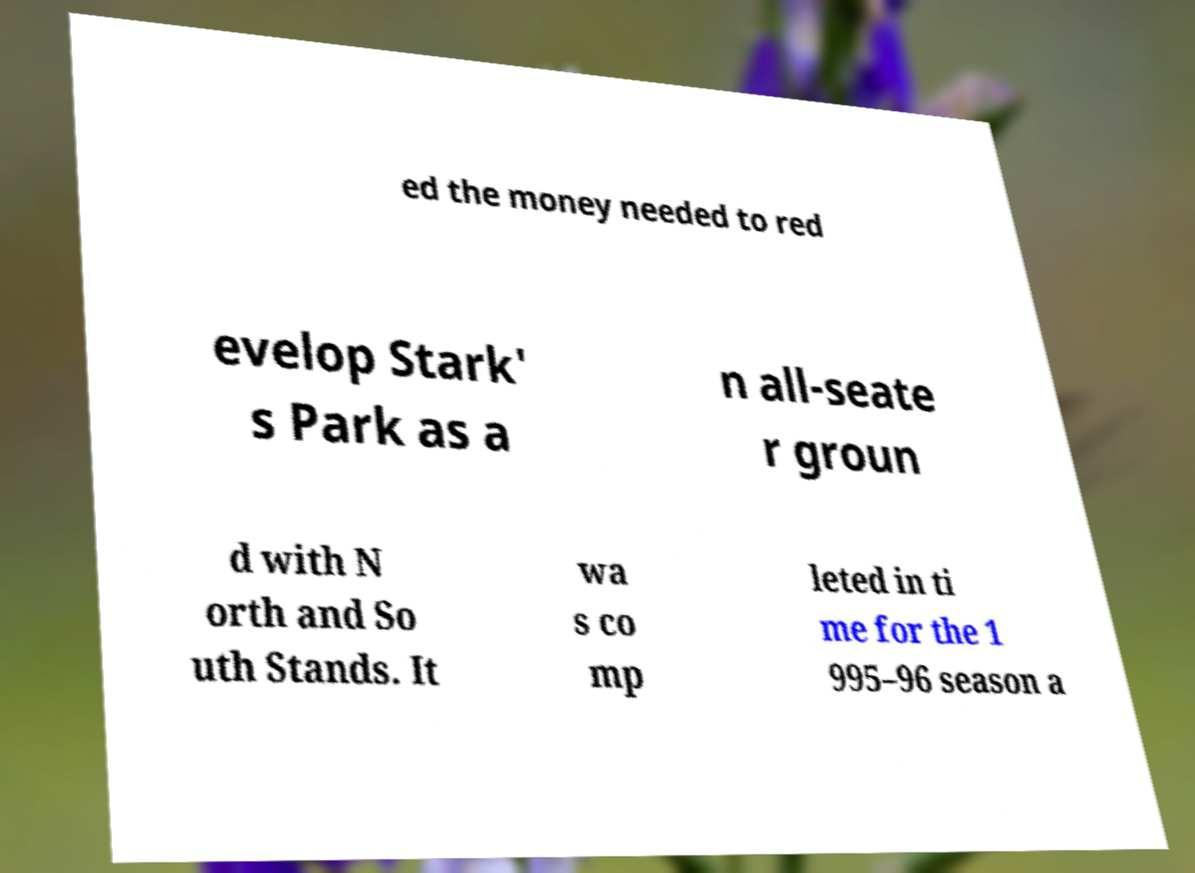Please read and relay the text visible in this image. What does it say? ed the money needed to red evelop Stark' s Park as a n all-seate r groun d with N orth and So uth Stands. It wa s co mp leted in ti me for the 1 995–96 season a 